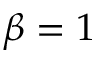<formula> <loc_0><loc_0><loc_500><loc_500>\beta = 1</formula> 